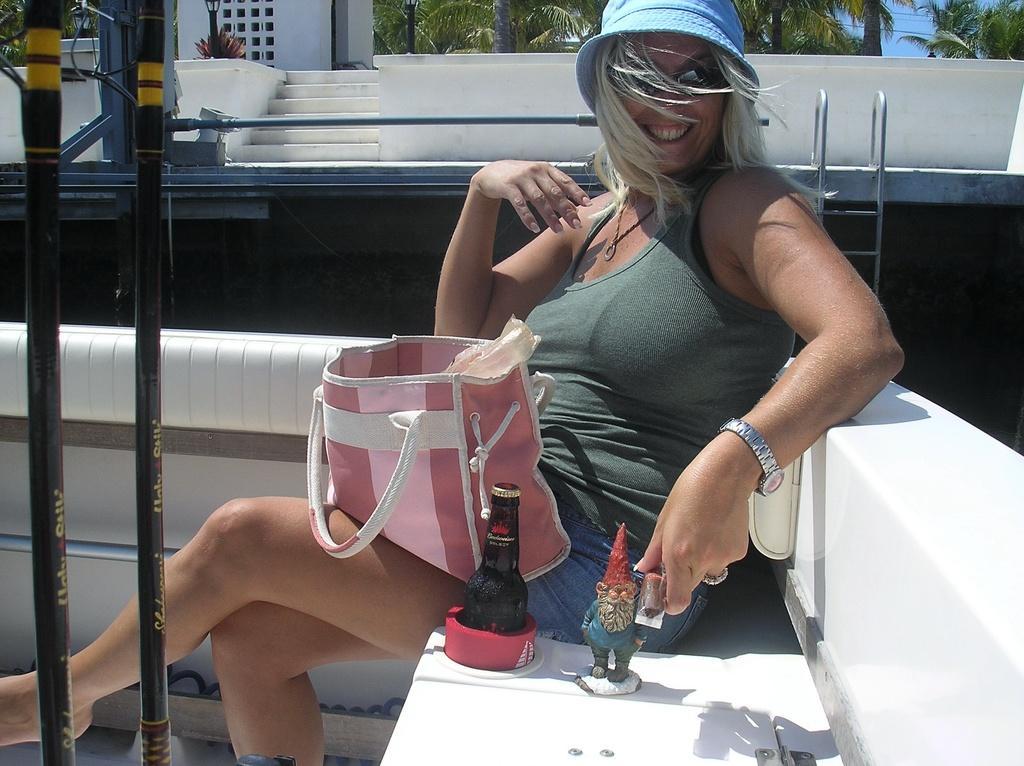How would you summarize this image in a sentence or two? In the foreground a woman is sitting on the bench, who is wearing a blue color hat and watch in her left hand and a pink color bag is kept on her thigh. Next to that a bottle is there and a toy is there. On the top trees are visible and sky visible blue in color. And a staircase and a house is visible of white in color. This image is taken on the boat during day time. 